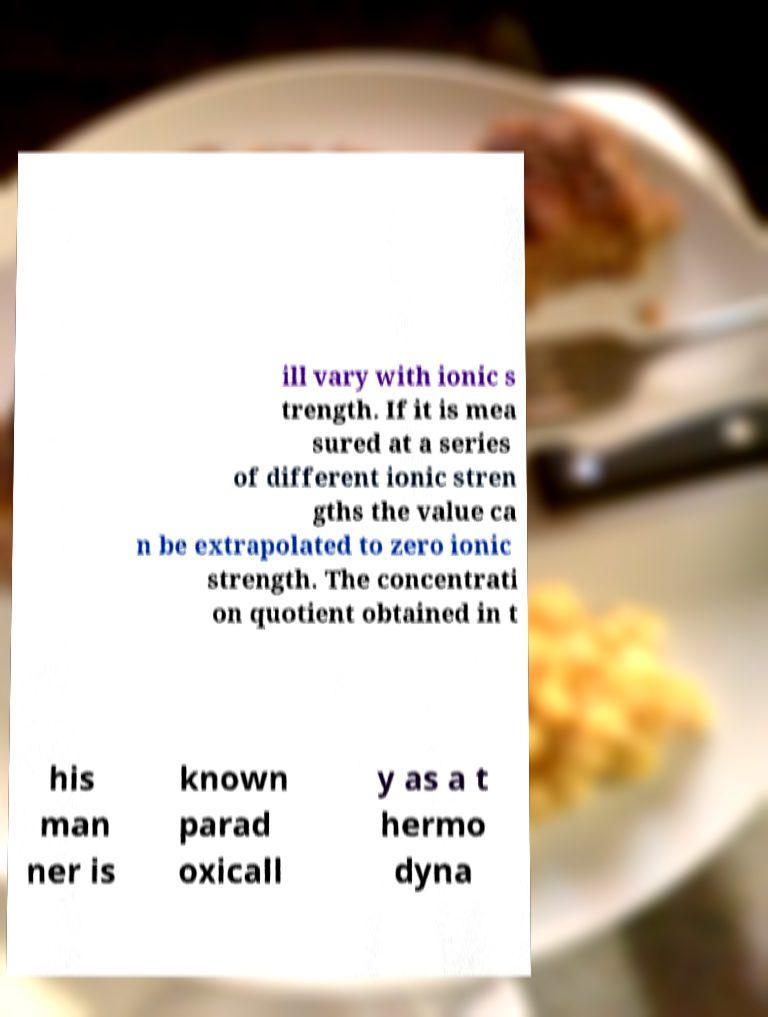There's text embedded in this image that I need extracted. Can you transcribe it verbatim? ill vary with ionic s trength. If it is mea sured at a series of different ionic stren gths the value ca n be extrapolated to zero ionic strength. The concentrati on quotient obtained in t his man ner is known parad oxicall y as a t hermo dyna 